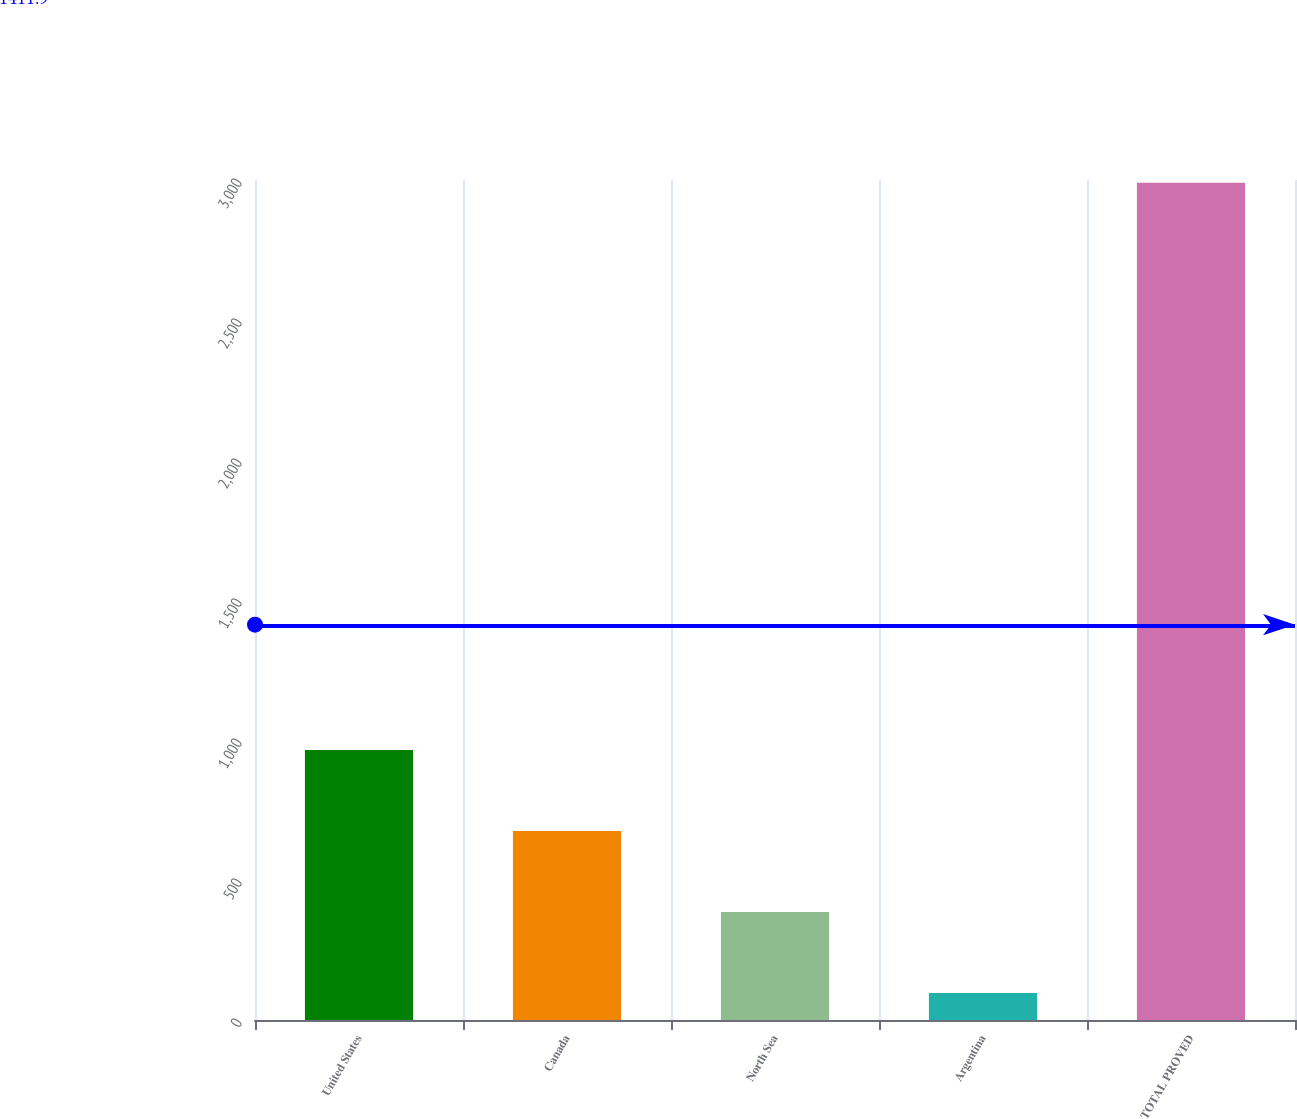<chart> <loc_0><loc_0><loc_500><loc_500><bar_chart><fcel>United States<fcel>Canada<fcel>North Sea<fcel>Argentina<fcel>TOTAL PROVED<nl><fcel>964.2<fcel>674.8<fcel>385.4<fcel>96<fcel>2990<nl></chart> 